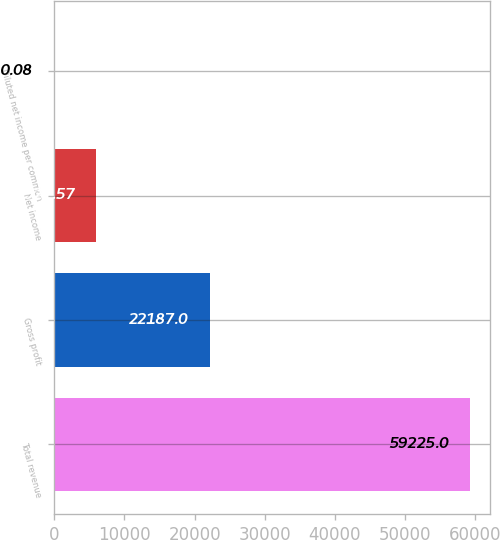<chart> <loc_0><loc_0><loc_500><loc_500><bar_chart><fcel>Total revenue<fcel>Gross profit<fcel>Net income<fcel>Diluted net income per common<nl><fcel>59225<fcel>22187<fcel>5922.57<fcel>0.08<nl></chart> 